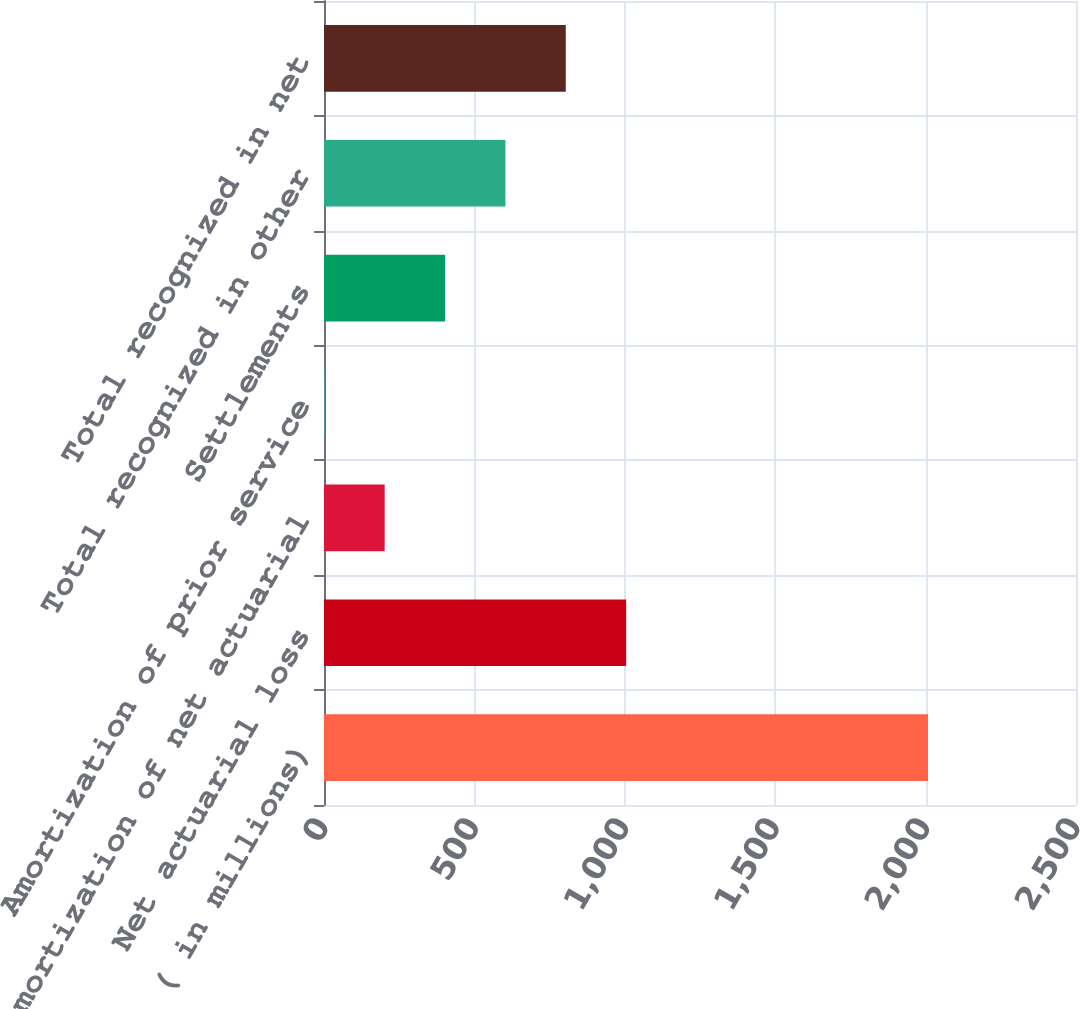Convert chart to OTSL. <chart><loc_0><loc_0><loc_500><loc_500><bar_chart><fcel>( in millions)<fcel>Net actuarial loss<fcel>Amortization of net actuarial<fcel>Amortization of prior service<fcel>Settlements<fcel>Total recognized in other<fcel>Total recognized in net<nl><fcel>2008<fcel>1004.5<fcel>201.7<fcel>1<fcel>402.4<fcel>603.1<fcel>803.8<nl></chart> 